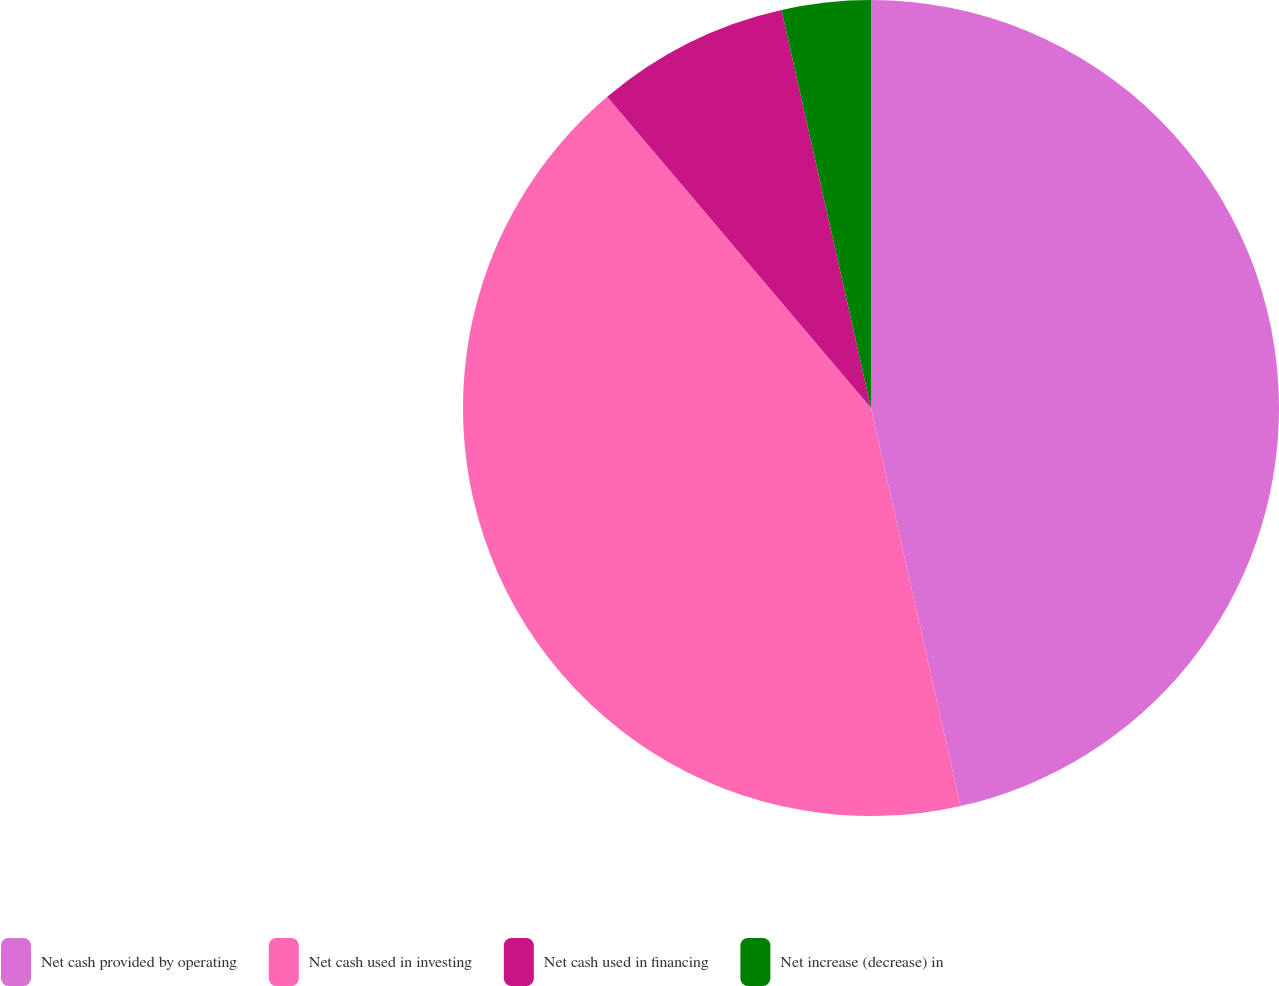Convert chart to OTSL. <chart><loc_0><loc_0><loc_500><loc_500><pie_chart><fcel>Net cash provided by operating<fcel>Net cash used in investing<fcel>Net cash used in financing<fcel>Net increase (decrease) in<nl><fcel>46.48%<fcel>42.33%<fcel>7.67%<fcel>3.52%<nl></chart> 